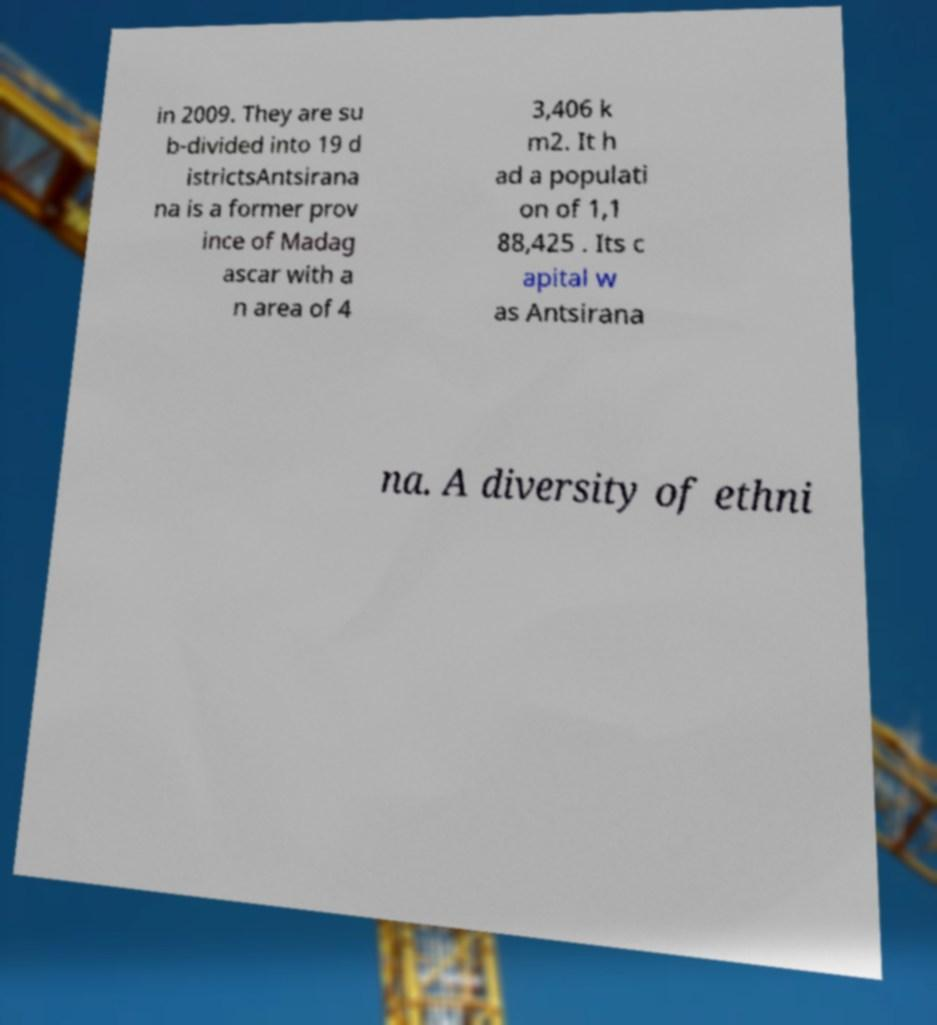Please identify and transcribe the text found in this image. in 2009. They are su b-divided into 19 d istrictsAntsirana na is a former prov ince of Madag ascar with a n area of 4 3,406 k m2. It h ad a populati on of 1,1 88,425 . Its c apital w as Antsirana na. A diversity of ethni 